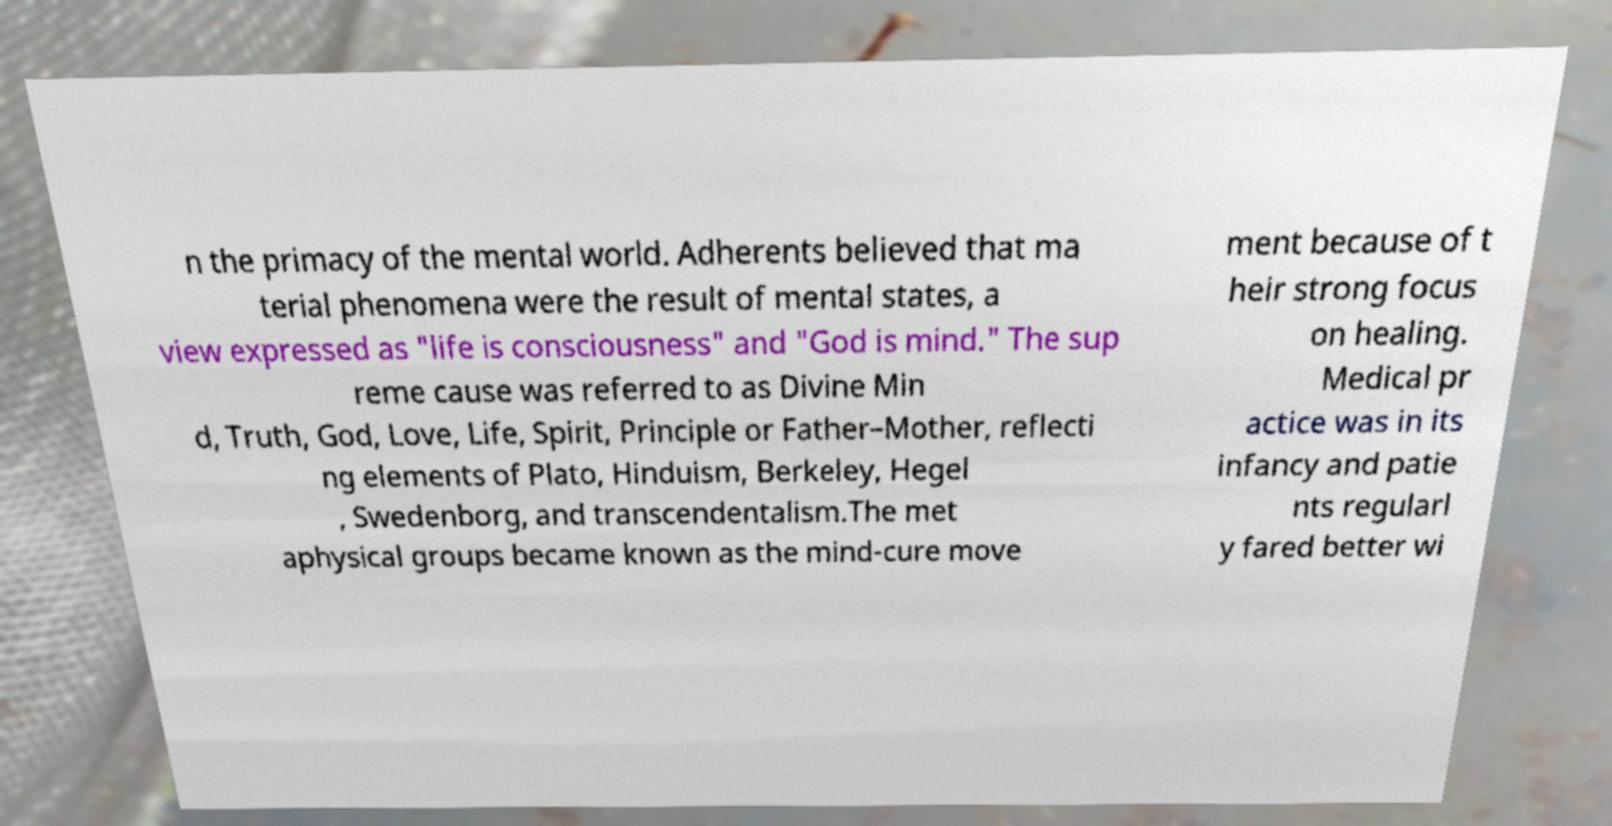There's text embedded in this image that I need extracted. Can you transcribe it verbatim? n the primacy of the mental world. Adherents believed that ma terial phenomena were the result of mental states, a view expressed as "life is consciousness" and "God is mind." The sup reme cause was referred to as Divine Min d, Truth, God, Love, Life, Spirit, Principle or Father–Mother, reflecti ng elements of Plato, Hinduism, Berkeley, Hegel , Swedenborg, and transcendentalism.The met aphysical groups became known as the mind-cure move ment because of t heir strong focus on healing. Medical pr actice was in its infancy and patie nts regularl y fared better wi 